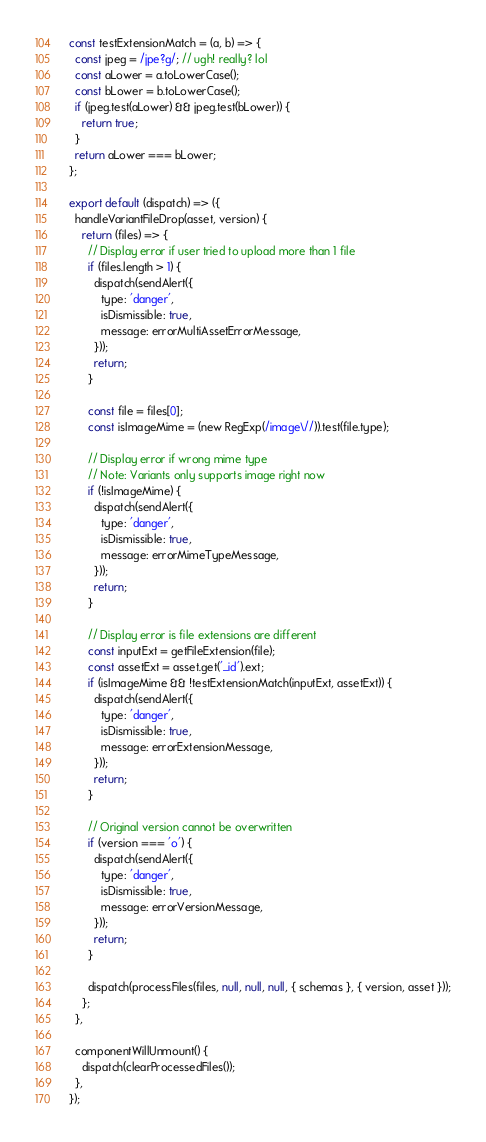Convert code to text. <code><loc_0><loc_0><loc_500><loc_500><_JavaScript_>const testExtensionMatch = (a, b) => {
  const jpeg = /jpe?g/; // ugh! really? lol
  const aLower = a.toLowerCase();
  const bLower = b.toLowerCase();
  if (jpeg.test(aLower) && jpeg.test(bLower)) {
    return true;
  }
  return aLower === bLower;
};

export default (dispatch) => ({
  handleVariantFileDrop(asset, version) {
    return (files) => {
      // Display error if user tried to upload more than 1 file
      if (files.length > 1) {
        dispatch(sendAlert({
          type: 'danger',
          isDismissible: true,
          message: errorMultiAssetErrorMessage,
        }));
        return;
      }

      const file = files[0];
      const isImageMime = (new RegExp(/image\//)).test(file.type);

      // Display error if wrong mime type
      // Note: Variants only supports image right now
      if (!isImageMime) {
        dispatch(sendAlert({
          type: 'danger',
          isDismissible: true,
          message: errorMimeTypeMessage,
        }));
        return;
      }

      // Display error is file extensions are different
      const inputExt = getFileExtension(file);
      const assetExt = asset.get('_id').ext;
      if (isImageMime && !testExtensionMatch(inputExt, assetExt)) {
        dispatch(sendAlert({
          type: 'danger',
          isDismissible: true,
          message: errorExtensionMessage,
        }));
        return;
      }

      // Original version cannot be overwritten
      if (version === 'o') {
        dispatch(sendAlert({
          type: 'danger',
          isDismissible: true,
          message: errorVersionMessage,
        }));
        return;
      }

      dispatch(processFiles(files, null, null, null, { schemas }, { version, asset }));
    };
  },

  componentWillUnmount() {
    dispatch(clearProcessedFiles());
  },
});
</code> 